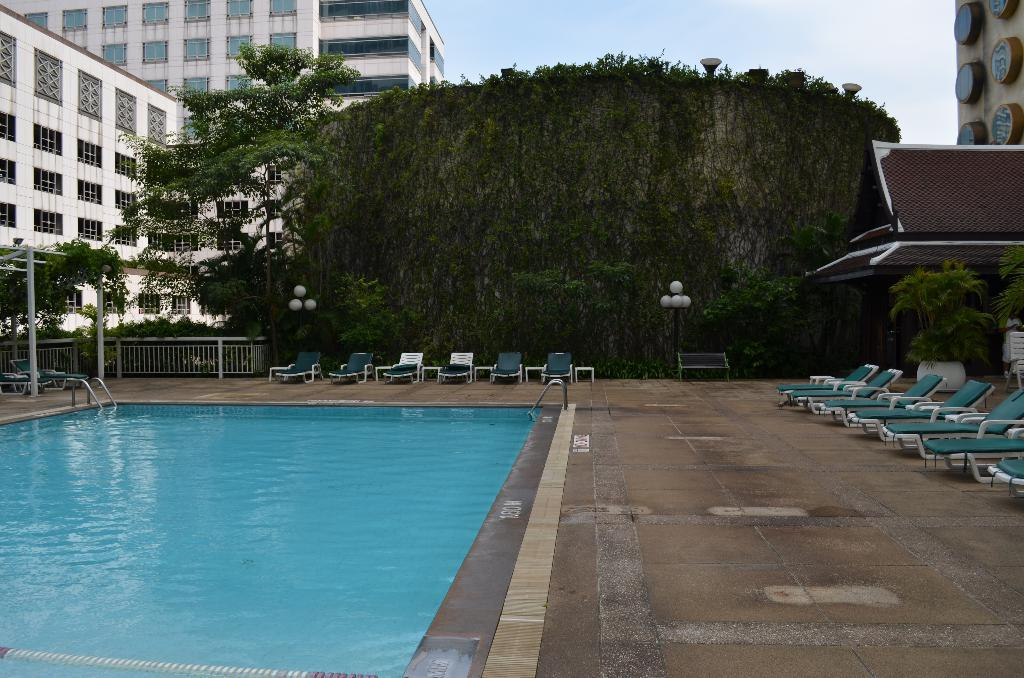What type of structures can be seen in the image? There are buildings in the image. Can you describe a specific part of one of the buildings? There is a window of a building in the image. What type of vegetation is present in the image? There are trees in the image. What type of barrier can be seen in the image? There is a fence in the image. What type of outdoor furniture is present in the image? There is a lounge chair and a bench in the image. What is the tall, thin object in the image? There is a pole in the image. What part of the natural environment is visible in the image? The sky is visible in the image. How many letters are visible on the lounge chair in the image? There are no letters visible on the lounge chair in the image. What type of mass can be seen in the image? There is no mass present in the image; it features buildings, trees, a fence, a lounge chair, a bench, a pole, and the sky. 